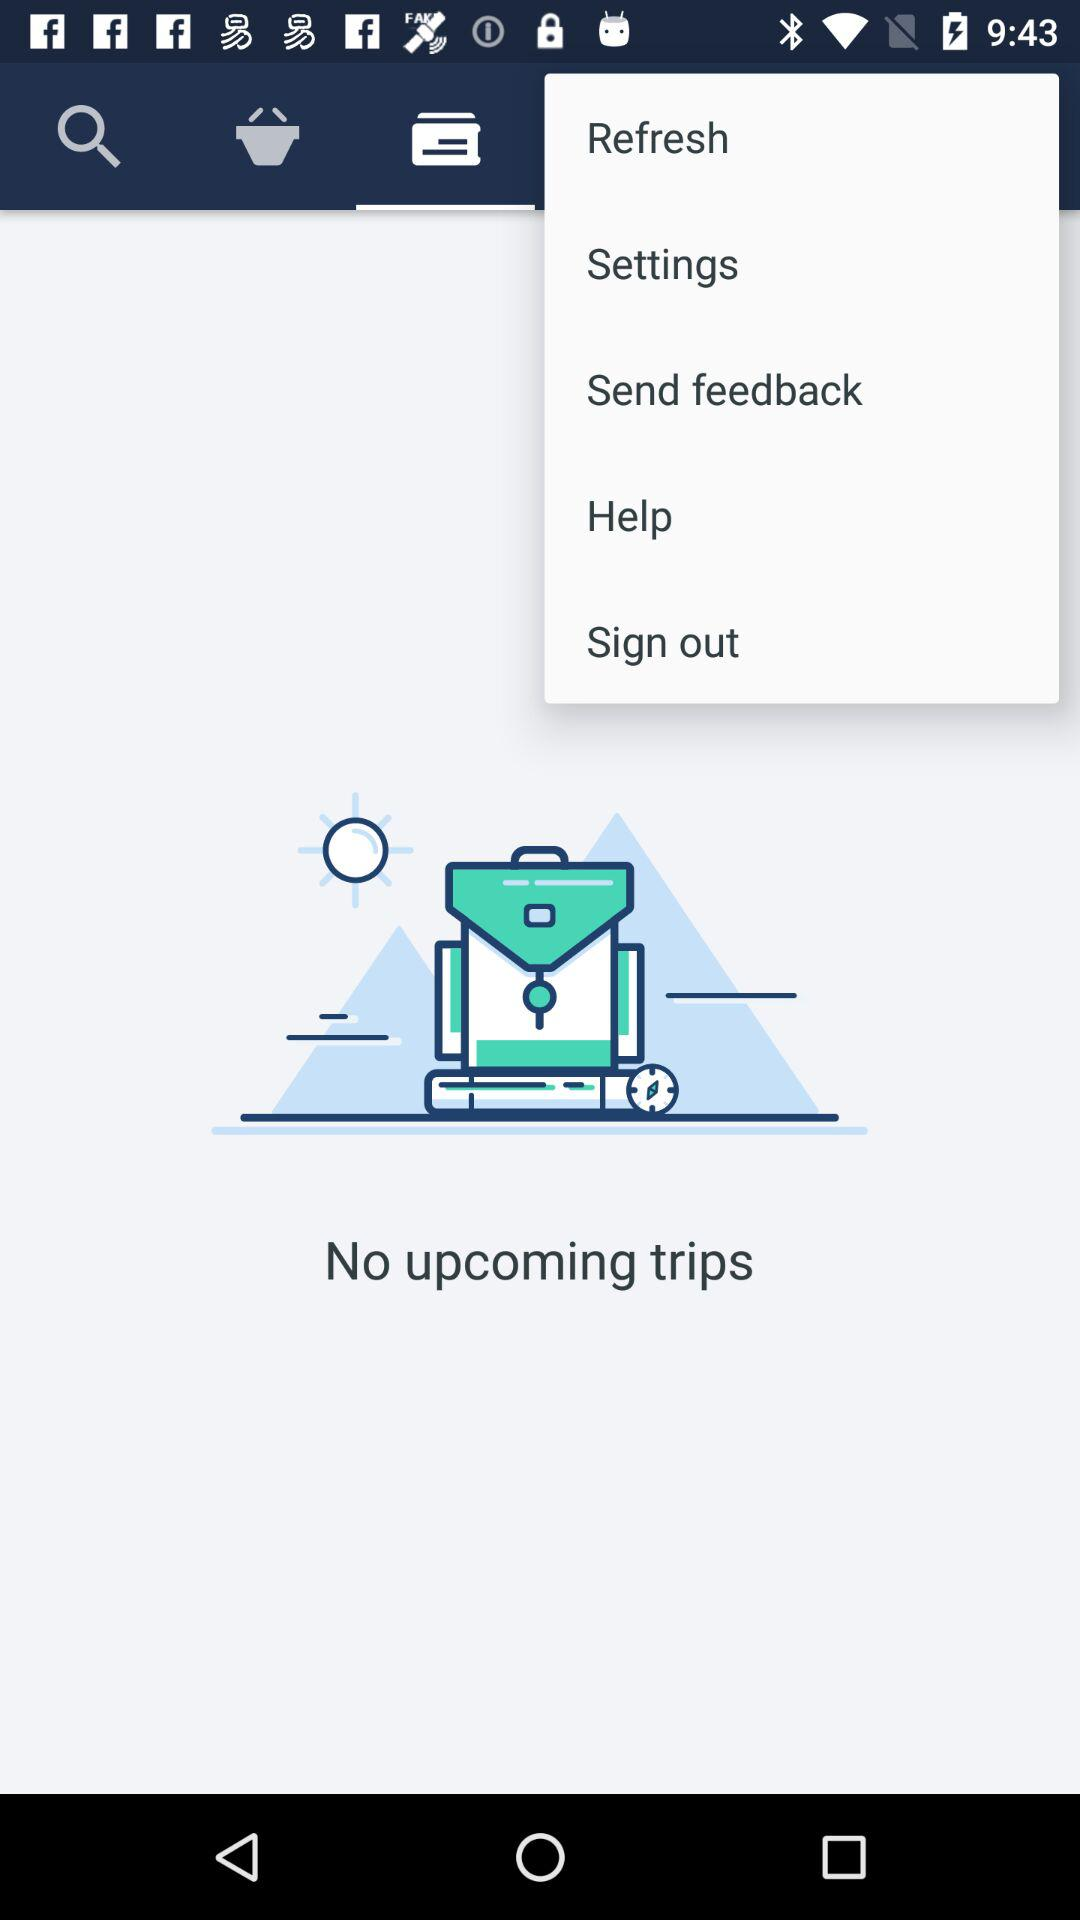Is there any upcoming trips? There are no upcoming trips. 